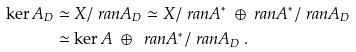<formula> <loc_0><loc_0><loc_500><loc_500>\ker A _ { D } & \simeq X / \ r a n A _ { D } \simeq X / \ r a n A ^ { * } \ \oplus \ r a n A ^ { * } / \ r a n A _ { D } \\ & \simeq \ker A \ \oplus \ \ r a n A ^ { * } / \ r a n A _ { D } \, .</formula> 